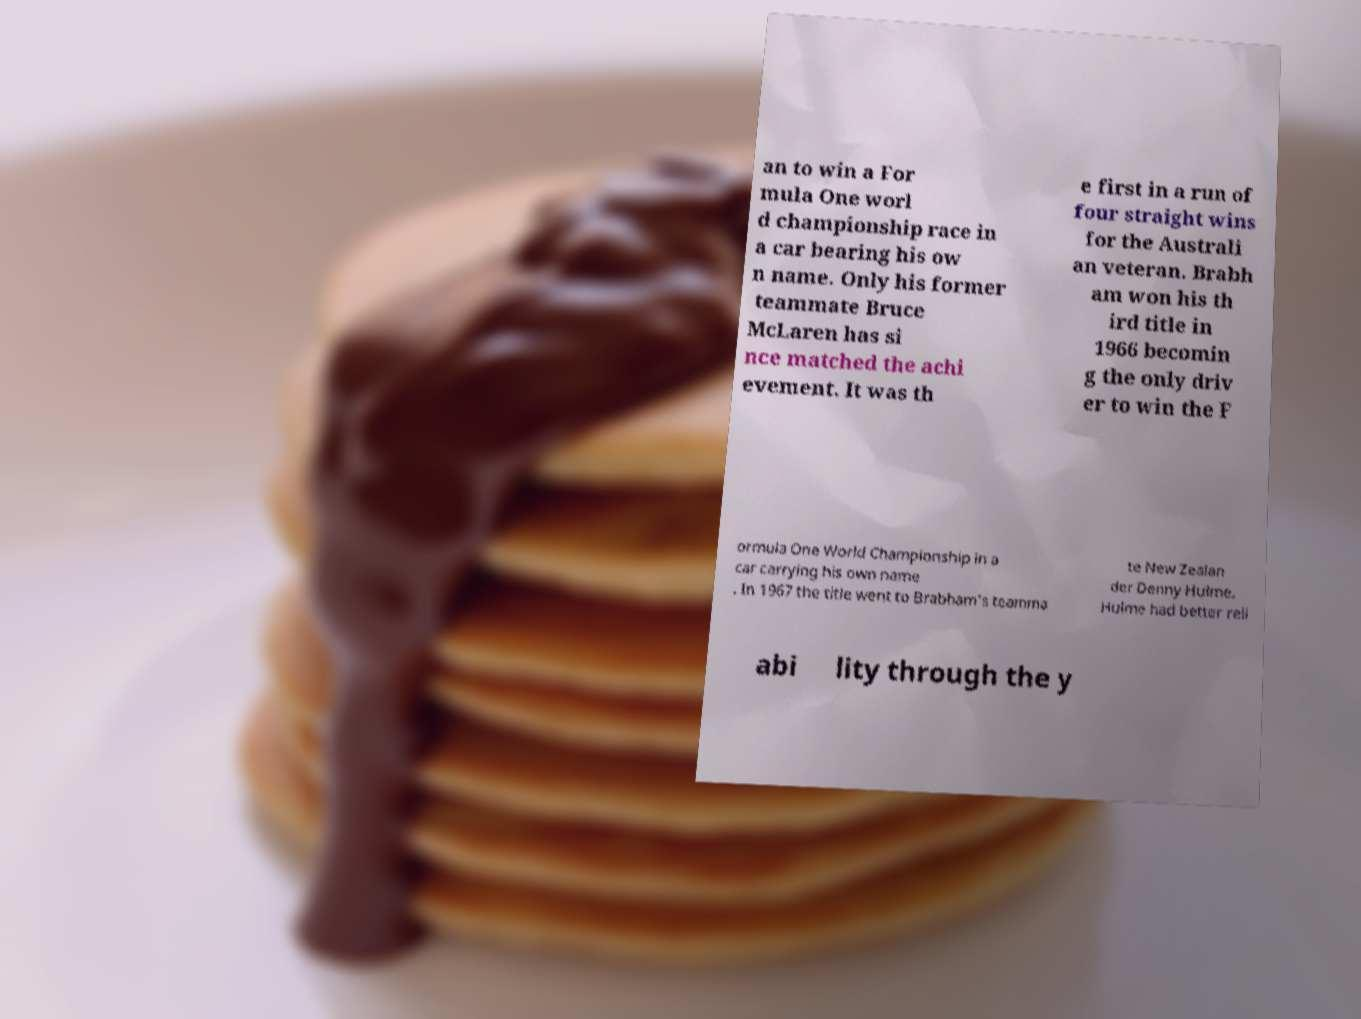There's text embedded in this image that I need extracted. Can you transcribe it verbatim? an to win a For mula One worl d championship race in a car bearing his ow n name. Only his former teammate Bruce McLaren has si nce matched the achi evement. It was th e first in a run of four straight wins for the Australi an veteran. Brabh am won his th ird title in 1966 becomin g the only driv er to win the F ormula One World Championship in a car carrying his own name . In 1967 the title went to Brabham's teamma te New Zealan der Denny Hulme. Hulme had better reli abi lity through the y 